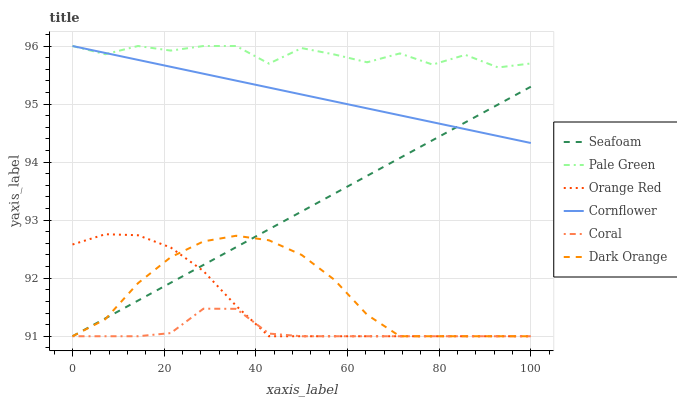Does Coral have the minimum area under the curve?
Answer yes or no. Yes. Does Pale Green have the maximum area under the curve?
Answer yes or no. Yes. Does Cornflower have the minimum area under the curve?
Answer yes or no. No. Does Cornflower have the maximum area under the curve?
Answer yes or no. No. Is Seafoam the smoothest?
Answer yes or no. Yes. Is Pale Green the roughest?
Answer yes or no. Yes. Is Cornflower the smoothest?
Answer yes or no. No. Is Cornflower the roughest?
Answer yes or no. No. Does Cornflower have the lowest value?
Answer yes or no. No. Does Pale Green have the highest value?
Answer yes or no. Yes. Does Coral have the highest value?
Answer yes or no. No. Is Dark Orange less than Pale Green?
Answer yes or no. Yes. Is Cornflower greater than Orange Red?
Answer yes or no. Yes. Does Dark Orange intersect Pale Green?
Answer yes or no. No. 